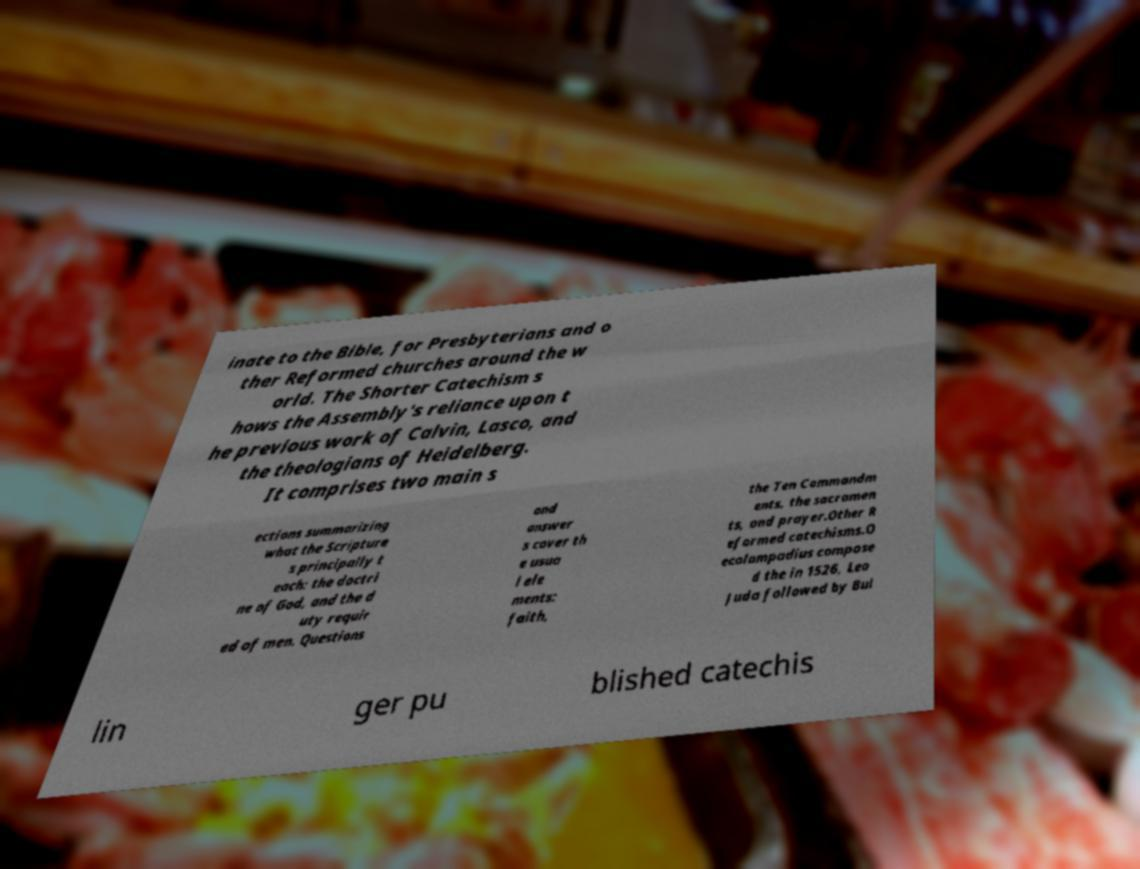For documentation purposes, I need the text within this image transcribed. Could you provide that? inate to the Bible, for Presbyterians and o ther Reformed churches around the w orld. The Shorter Catechism s hows the Assembly's reliance upon t he previous work of Calvin, Lasco, and the theologians of Heidelberg. It comprises two main s ections summarizing what the Scripture s principally t each: the doctri ne of God, and the d uty requir ed of men. Questions and answer s cover th e usua l ele ments: faith, the Ten Commandm ents, the sacramen ts, and prayer.Other R eformed catechisms.O ecolampadius compose d the in 1526, Leo Juda followed by Bul lin ger pu blished catechis 